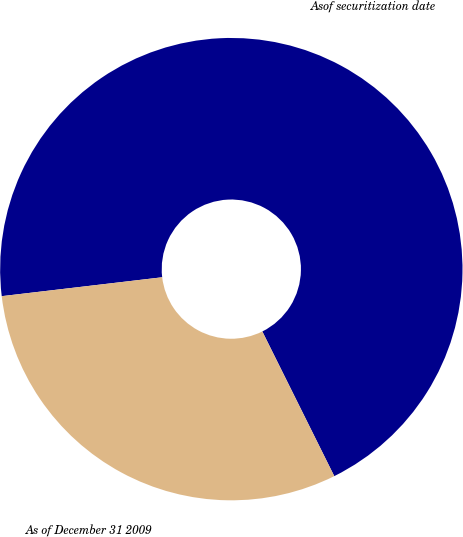Convert chart. <chart><loc_0><loc_0><loc_500><loc_500><pie_chart><fcel>Asof securitization date<fcel>As of December 31 2009<nl><fcel>69.52%<fcel>30.48%<nl></chart> 